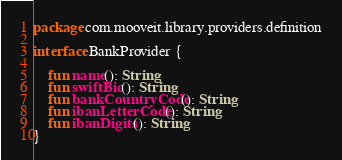Convert code to text. <code><loc_0><loc_0><loc_500><loc_500><_Kotlin_>package com.mooveit.library.providers.definition

interface BankProvider {

    fun name(): String
    fun swiftBic(): String
    fun bankCountryCode(): String
    fun ibanLetterCode(): String
    fun ibanDigits(): String
}</code> 